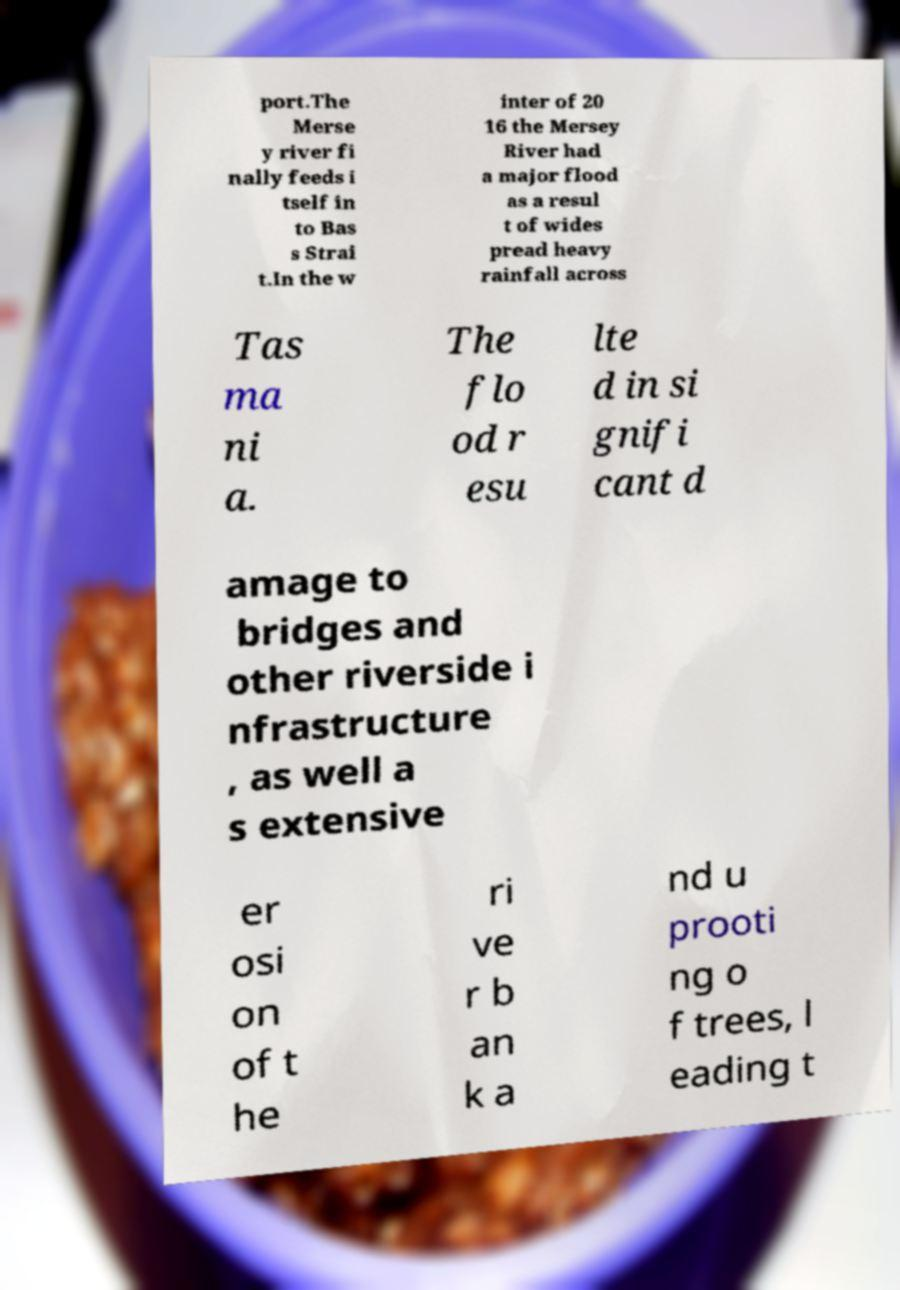Please read and relay the text visible in this image. What does it say? port.The Merse y river fi nally feeds i tself in to Bas s Strai t.In the w inter of 20 16 the Mersey River had a major flood as a resul t of wides pread heavy rainfall across Tas ma ni a. The flo od r esu lte d in si gnifi cant d amage to bridges and other riverside i nfrastructure , as well a s extensive er osi on of t he ri ve r b an k a nd u prooti ng o f trees, l eading t 